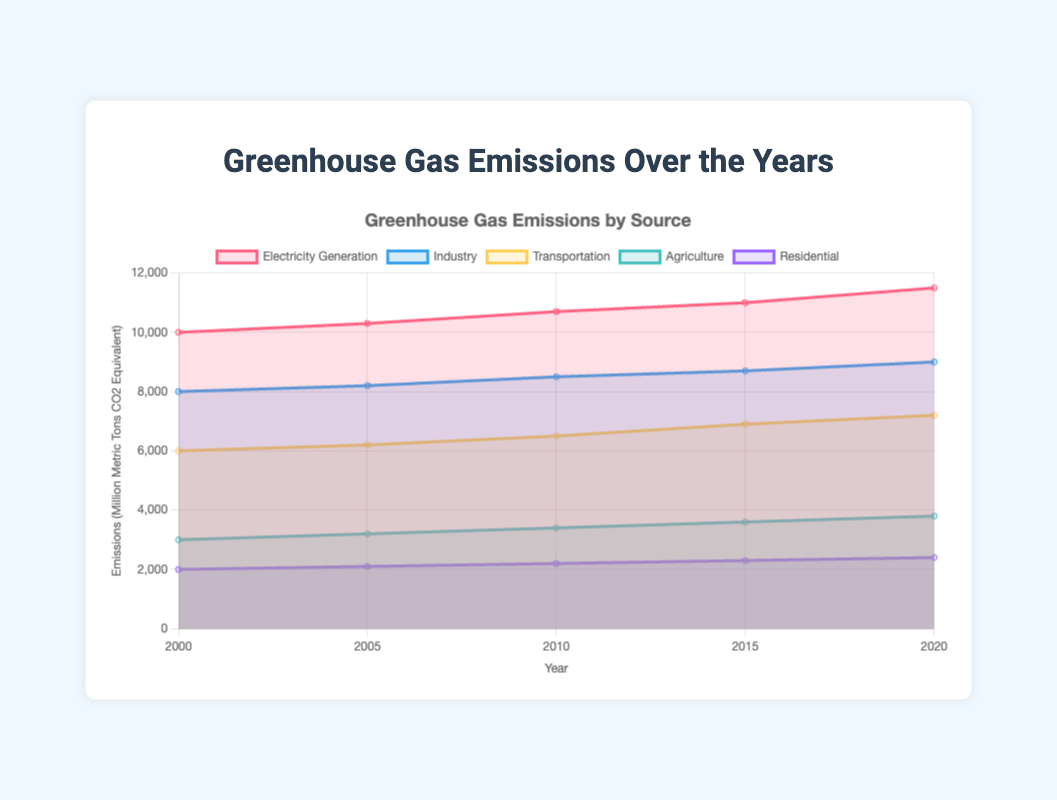What sources of greenhouse gas emissions have been tracked in this figure? The five sources of greenhouse gas emissions tracked in the figure are Electricity Generation, Industry, Transportation, Agriculture, and Residential.
Answer: Electricity Generation, Industry, Transportation, Agriculture, Residential What is the overall trend for emissions from transportation? The emissions from transportation show an increasing trend over the years from 6000 in 2000 to 7200 in 2020.
Answer: Increasing Which source has the highest emissions in 2020? By looking at the data for 2020, Electricity Generation has the highest emissions at 11500 million metric tons CO2 equivalent.
Answer: Electricity Generation How much did the industry emissions increase from 2000 to 2020? The industry emissions were 8000 in 2000 and increased to 9000 in 2020. The difference is 9000 - 8000 = 1000 million metric tons CO2 equivalent.
Answer: 1000 By how much did the residential emissions change from 2000 to 2020? The residential emissions were 2000 in 2000 and increased to 2400 in 2020, resulting in a change of 2400 - 2000 = 400 million metric tons CO2 equivalent.
Answer: 400 Among all sources, which one shows the smallest increase in emissions over the years? The residential sector shows the smallest increase in emissions, rising from 2000 in 2000 to 2400 in 2020, a difference of 400 million metric tons CO2 equivalent.
Answer: Residential What is the range of agriculture emissions from 2000 to 2020? The lowest agriculture emissions were 3000 in 2000, and the highest were 3800 in 2020. The range is 3800 - 3000 = 800 million metric tons CO2 equivalent.
Answer: 800 In which year did electricity generation emissions first reach 11000? By looking at the data, electricity generation emissions first reached 11000 in the year 2015.
Answer: 2015 Which two sources have the closest emission values in 2020? In 2020, industry emissions are 9000 and transportation emissions are 7200. Among all pairs, the industry and transportation have the closest values, with a difference of 1800 (9000 - 7200).
Answer: Industry and Transportation 